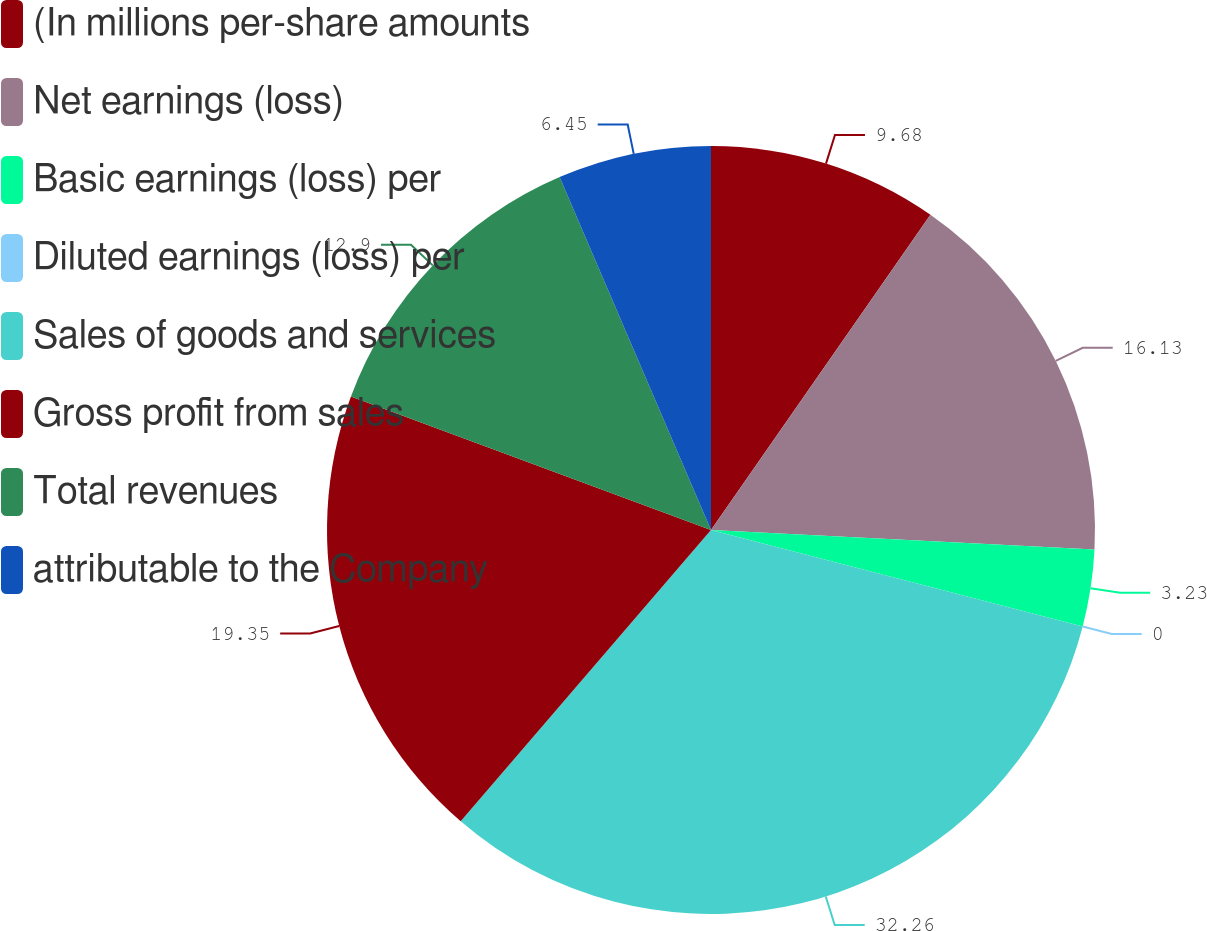<chart> <loc_0><loc_0><loc_500><loc_500><pie_chart><fcel>(In millions per-share amounts<fcel>Net earnings (loss)<fcel>Basic earnings (loss) per<fcel>Diluted earnings (loss) per<fcel>Sales of goods and services<fcel>Gross profit from sales<fcel>Total revenues<fcel>attributable to the Company<nl><fcel>9.68%<fcel>16.13%<fcel>3.23%<fcel>0.0%<fcel>32.26%<fcel>19.35%<fcel>12.9%<fcel>6.45%<nl></chart> 